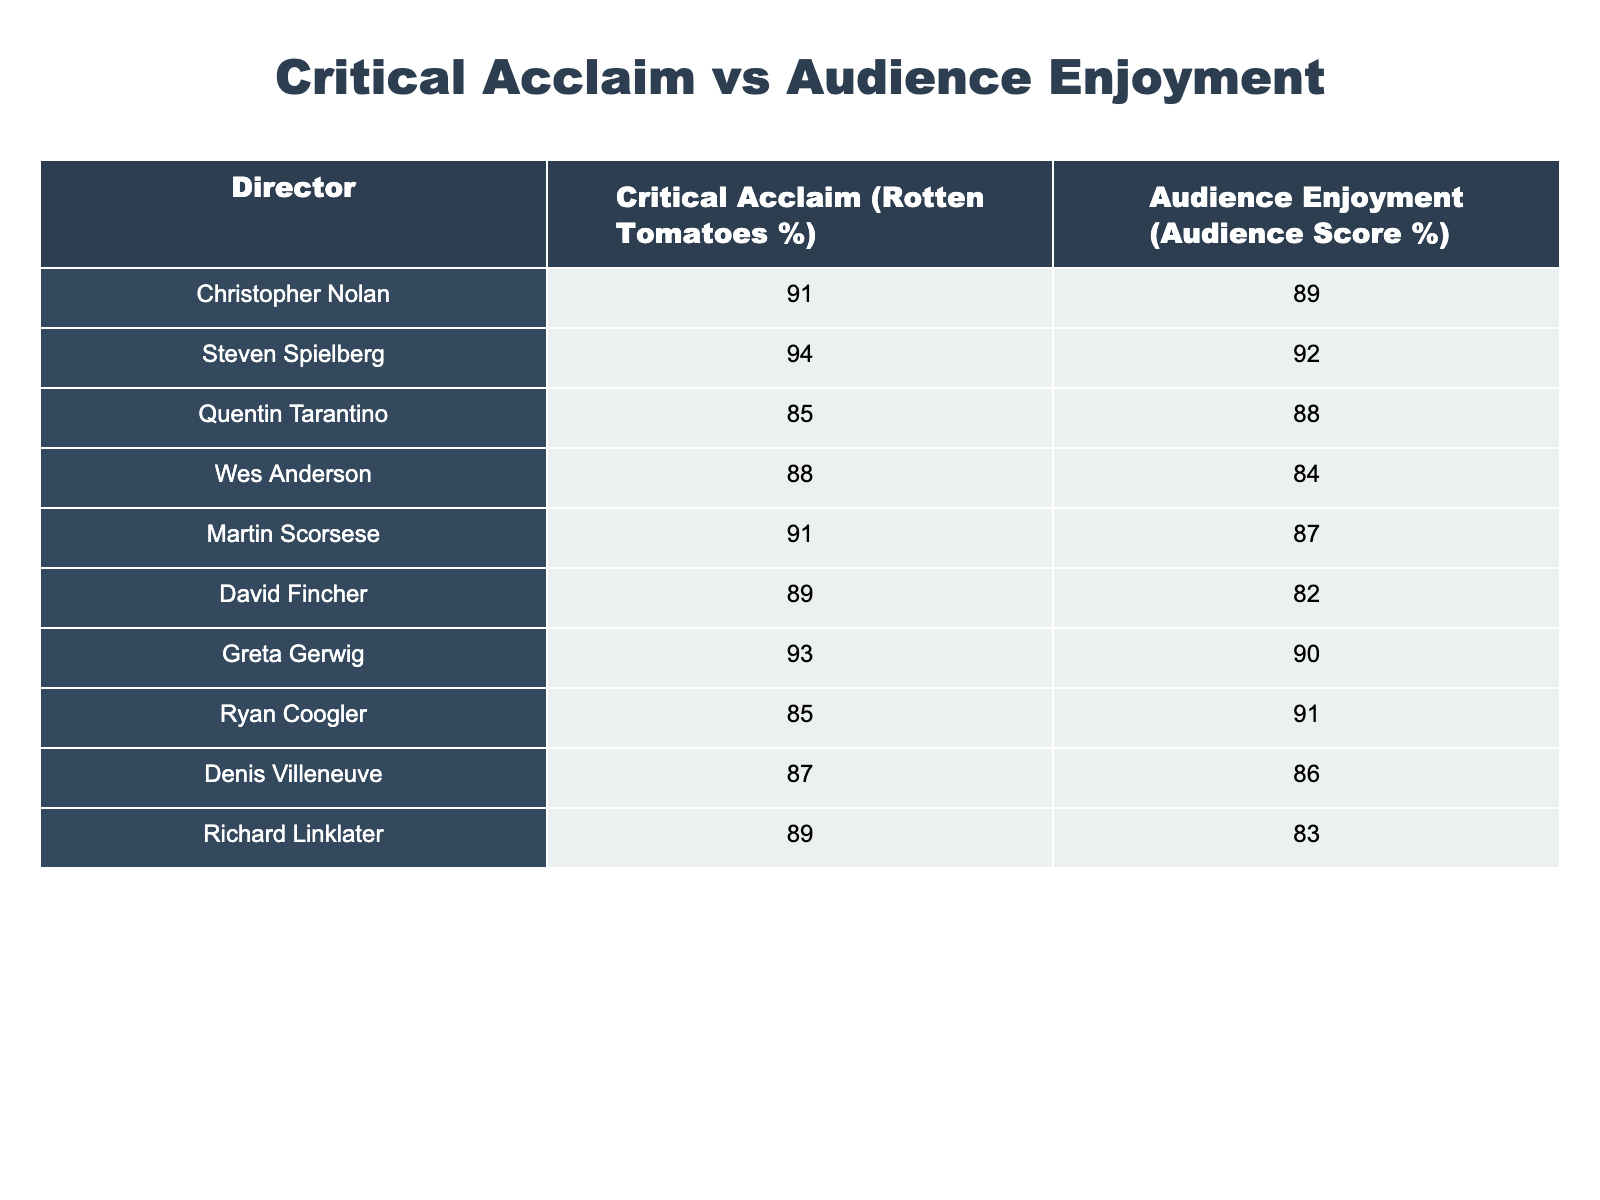What is the critical acclaim percentage of Steven Spielberg? The critical acclaim percentage for Steven Spielberg is listed directly in the table under the "Critical Acclaim (Rotten Tomatoes %)" column, which shows a value of 94.
Answer: 94 Which director has the lowest audience enjoyment percentage? Ryan Coogler has the lowest audience enjoyment percentage of 85, which can be found by inspecting the "Audience Enjoyment (Audience Score %)" column and identifying the smallest number.
Answer: 85 What is the average critical acclaim percentage for all the directors listed? To calculate the average, sum all the critical acclaim percentages: 91 + 94 + 85 + 88 + 91 + 89 + 93 + 85 + 87 + 89 = 900. Since there are 10 directors, divide 900 by 10 to get the average, which is 90.
Answer: 90 Is it true that Martin Scorsese has a higher audience enjoyment percentage than Denis Villeneuve? By comparing the audience enjoyment percentages, Martin Scorsese has a score of 87, while Denis Villeneuve has a score of 86. Since 87 is greater than 86, the statement is true.
Answer: Yes What is the difference between the highest and lowest critical acclaim percentages? The highest critical acclaim percentage is for Steven Spielberg at 94, and the lowest is Quentin Tarantino at 85. The difference is 94 - 85 = 9.
Answer: 9 Which director has both critical acclaim and audience enjoyment percentages above 90? Looking through both columns, Steven Spielberg with a critical acclaim of 94 and audience enjoyment of 92, and Greta Gerwig with a critical acclaim of 93 and audience enjoyment of 90, are both above 90. Thus, the directors are Steven Spielberg and Greta Gerwig.
Answer: Steven Spielberg and Greta Gerwig How many directors have an audience enjoyment percentage below 85? By examining the "Audience Enjoyment (Audience Score %)" column, none of the directors have a score lower than 84, which is the lowest value found. Thus, the count of directors below 85 is 0.
Answer: 0 What is the average audience enjoyment percentage for directors whose critical acclaim is above 90? The directors with critical acclaim above 90 are Steven Spielberg (92), Greta Gerwig (90), and Christopher Nolan (89). Their audience enjoyment percentages are 92, 90, and 89. Summing these gives 92 + 90 + 89 = 271. Divide by 3 for the average, which is approximately 90.33.
Answer: 90.33 